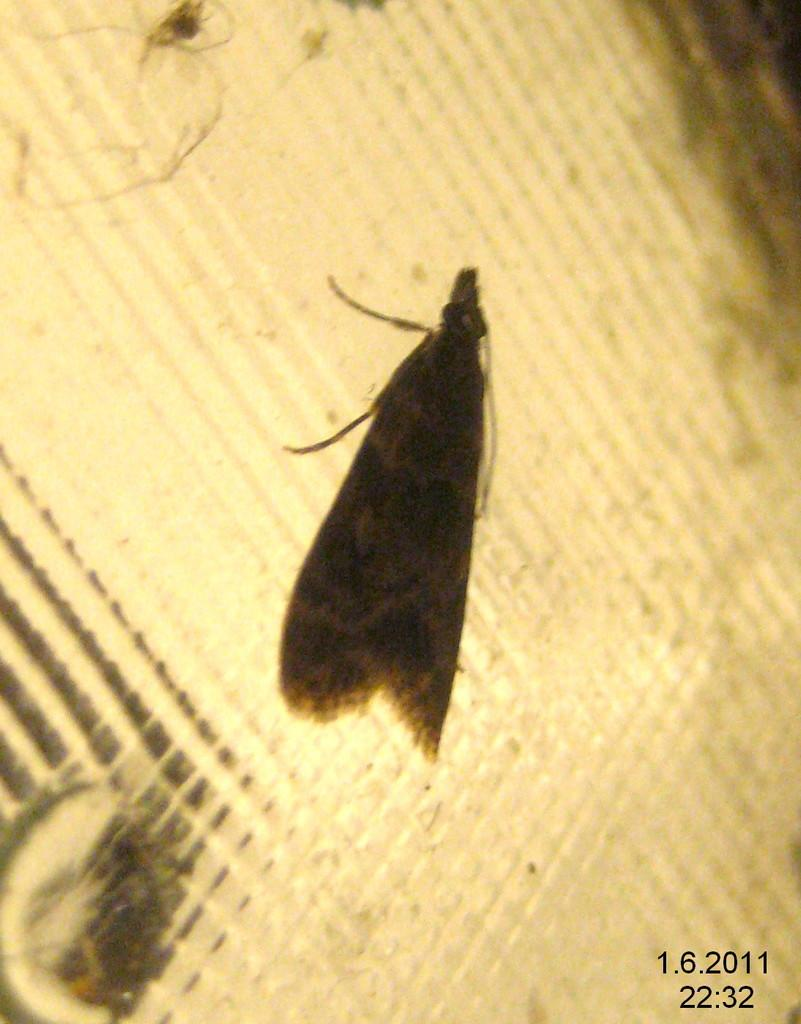What type of creature can be seen in the image? There is an insect in the image. Can you describe the background of the image? The background of the image is blurry. Is there any text present in the image? Yes, there is some text in the bottom right-hand corner of the image. Can you tell me how many bats are flying in the image? There are no bats present in the image; it features an insect. What type of sail can be seen in the image? There is no sail present in the image. 